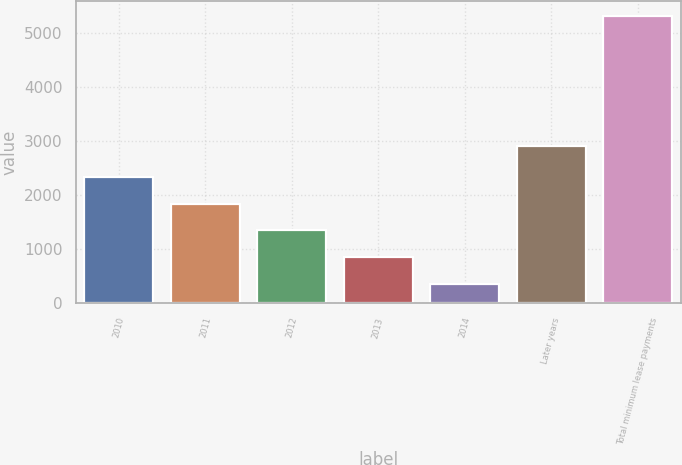Convert chart to OTSL. <chart><loc_0><loc_0><loc_500><loc_500><bar_chart><fcel>2010<fcel>2011<fcel>2012<fcel>2013<fcel>2014<fcel>Later years<fcel>Total minimum lease payments<nl><fcel>2336<fcel>1840<fcel>1344<fcel>848<fcel>352<fcel>2901<fcel>5312<nl></chart> 